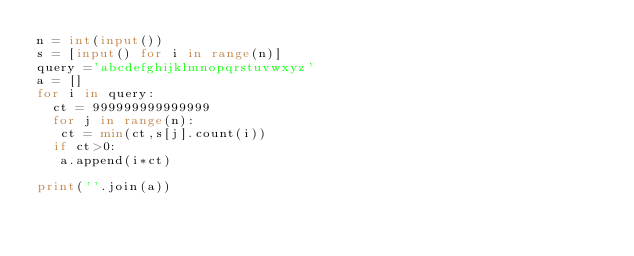Convert code to text. <code><loc_0><loc_0><loc_500><loc_500><_Python_>n = int(input())
s = [input() for i in range(n)]
query ='abcdefghijklmnopqrstuvwxyz'
a = []
for i in query:
  ct = 999999999999999
  for j in range(n):
   ct = min(ct,s[j].count(i))
  if ct>0:
   a.append(i*ct)

print(''.join(a))</code> 